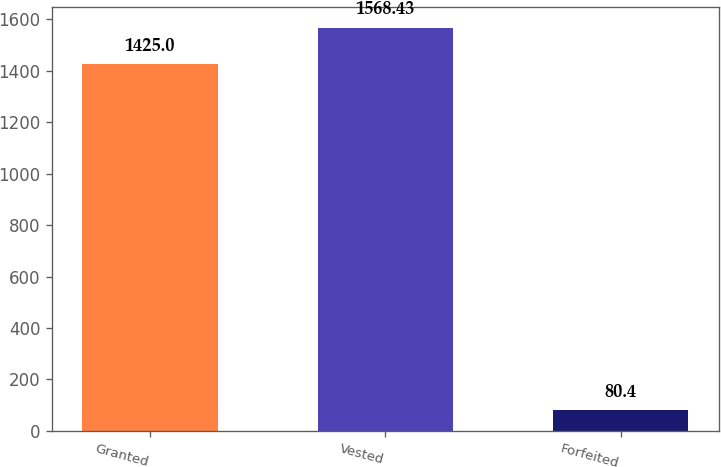Convert chart. <chart><loc_0><loc_0><loc_500><loc_500><bar_chart><fcel>Granted<fcel>Vested<fcel>Forfeited<nl><fcel>1425<fcel>1568.43<fcel>80.4<nl></chart> 